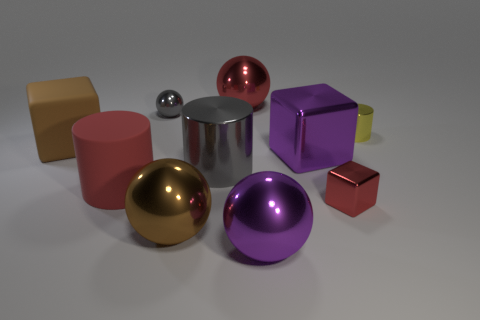Subtract all large cylinders. How many cylinders are left? 1 Subtract all gray balls. How many balls are left? 3 Subtract 3 spheres. How many spheres are left? 1 Subtract 0 green cylinders. How many objects are left? 10 Subtract all cubes. How many objects are left? 7 Subtract all gray blocks. Subtract all gray cylinders. How many blocks are left? 3 Subtract all yellow cylinders. How many green cubes are left? 0 Subtract all tiny red matte blocks. Subtract all metal cylinders. How many objects are left? 8 Add 2 brown matte things. How many brown matte things are left? 3 Add 9 red blocks. How many red blocks exist? 10 